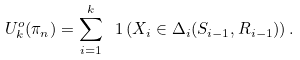<formula> <loc_0><loc_0><loc_500><loc_500>U ^ { o } _ { k } ( \pi _ { n } ) = \sum _ { i = 1 } ^ { k } \ 1 \left ( X _ { i } \in \Delta _ { i } ( S _ { i - 1 } , R _ { i - 1 } ) \right ) .</formula> 